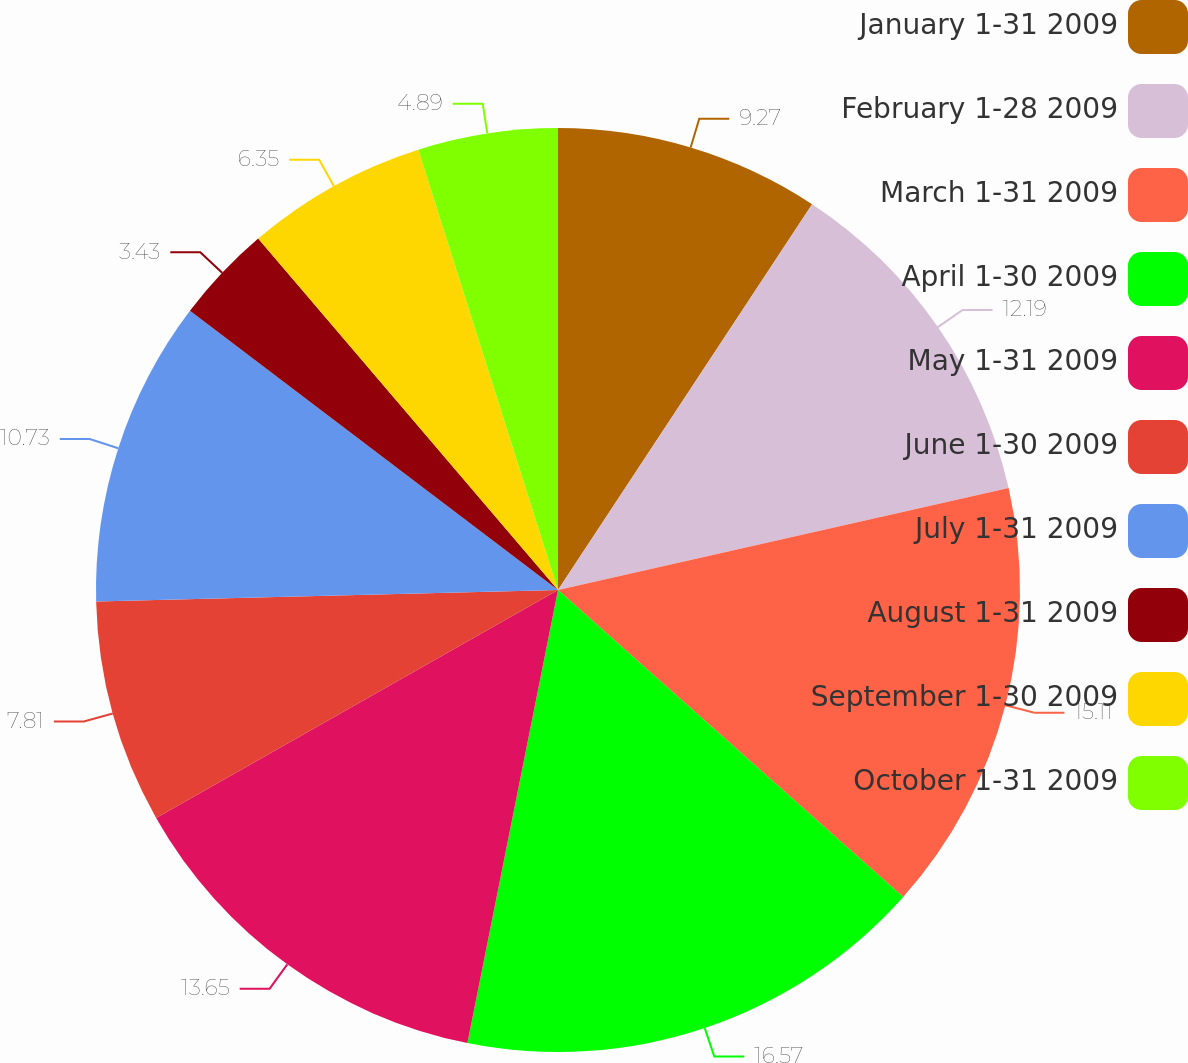<chart> <loc_0><loc_0><loc_500><loc_500><pie_chart><fcel>January 1-31 2009<fcel>February 1-28 2009<fcel>March 1-31 2009<fcel>April 1-30 2009<fcel>May 1-31 2009<fcel>June 1-30 2009<fcel>July 1-31 2009<fcel>August 1-31 2009<fcel>September 1-30 2009<fcel>October 1-31 2009<nl><fcel>9.27%<fcel>12.19%<fcel>15.11%<fcel>16.57%<fcel>13.65%<fcel>7.81%<fcel>10.73%<fcel>3.43%<fcel>6.35%<fcel>4.89%<nl></chart> 